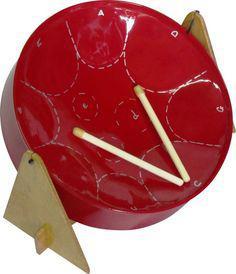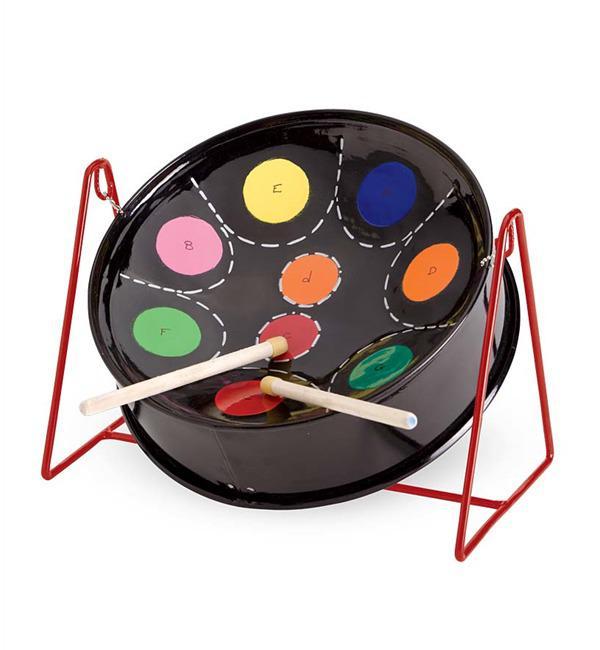The first image is the image on the left, the second image is the image on the right. Considering the images on both sides, is "All the drumsticks are resting on the drum head." valid? Answer yes or no. Yes. The first image is the image on the left, the second image is the image on the right. Examine the images to the left and right. Is the description "Each image shows one tilted cylindrical bowl-type drum on a pivoting stand, and the drum on the right has a red exterior and black bowl top." accurate? Answer yes or no. No. 